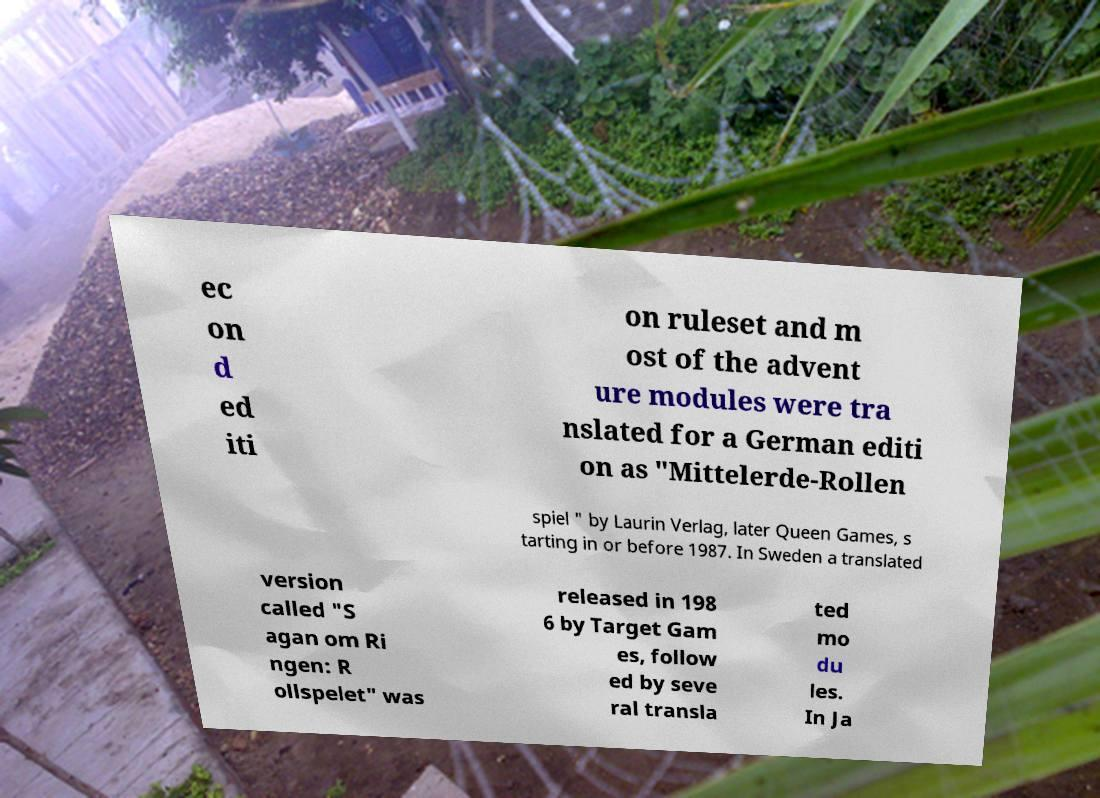Could you assist in decoding the text presented in this image and type it out clearly? ec on d ed iti on ruleset and m ost of the advent ure modules were tra nslated for a German editi on as "Mittelerde-Rollen spiel " by Laurin Verlag, later Queen Games, s tarting in or before 1987. In Sweden a translated version called "S agan om Ri ngen: R ollspelet" was released in 198 6 by Target Gam es, follow ed by seve ral transla ted mo du les. In Ja 